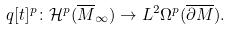Convert formula to latex. <formula><loc_0><loc_0><loc_500><loc_500>q [ t ] ^ { p } \colon { \mathcal { H } } ^ { p } ( \overline { M } _ { \infty } ) \to L ^ { 2 } \Omega ^ { p } ( \overline { \partial M } ) .</formula> 